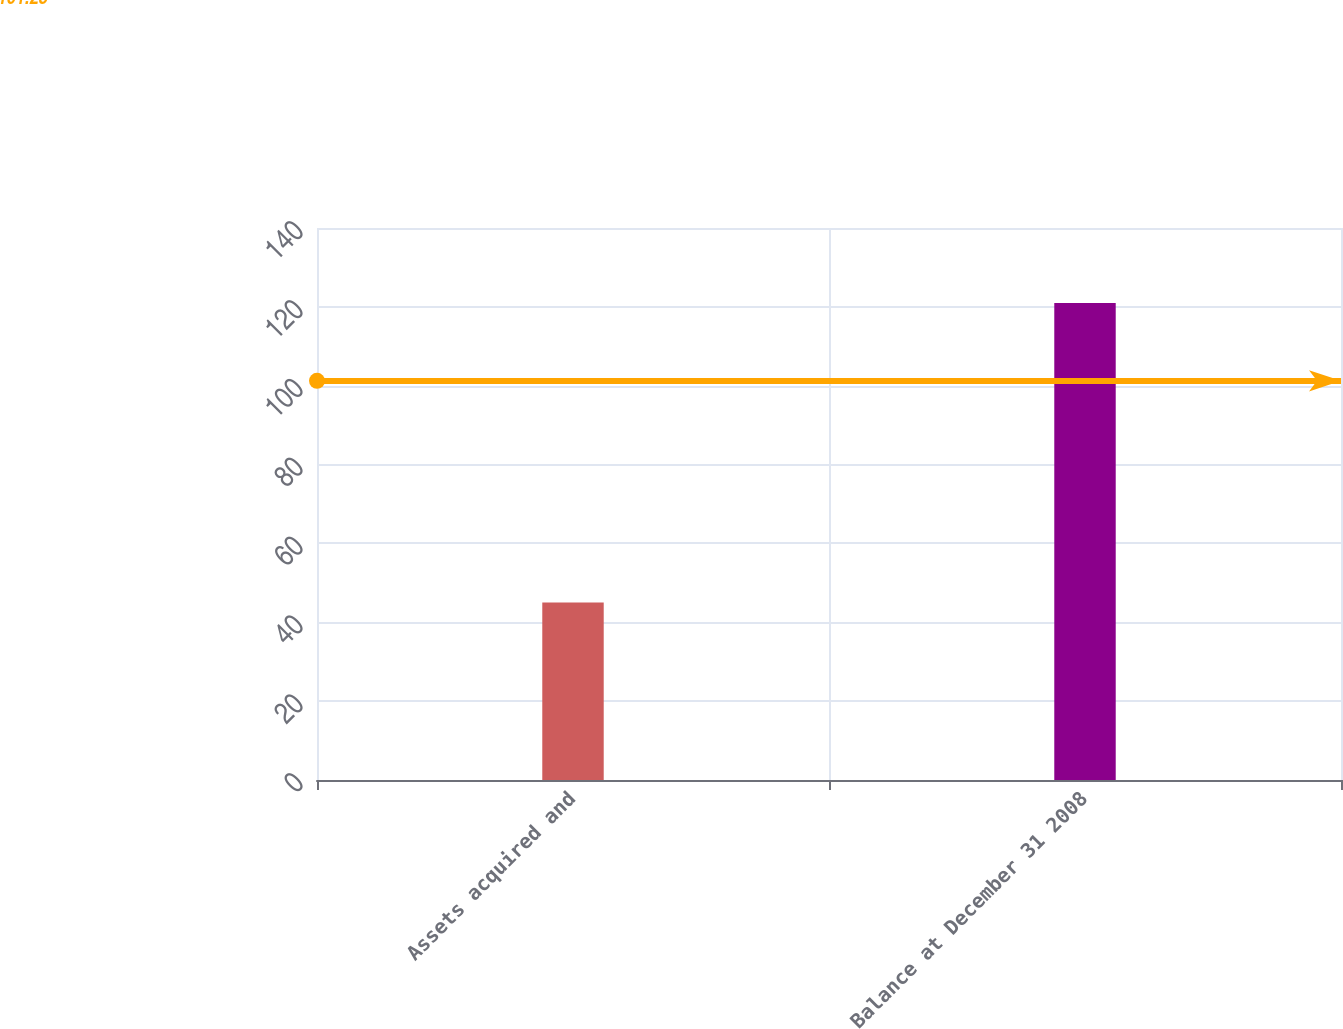<chart> <loc_0><loc_0><loc_500><loc_500><bar_chart><fcel>Assets acquired and<fcel>Balance at December 31 2008<nl><fcel>45<fcel>121<nl></chart> 